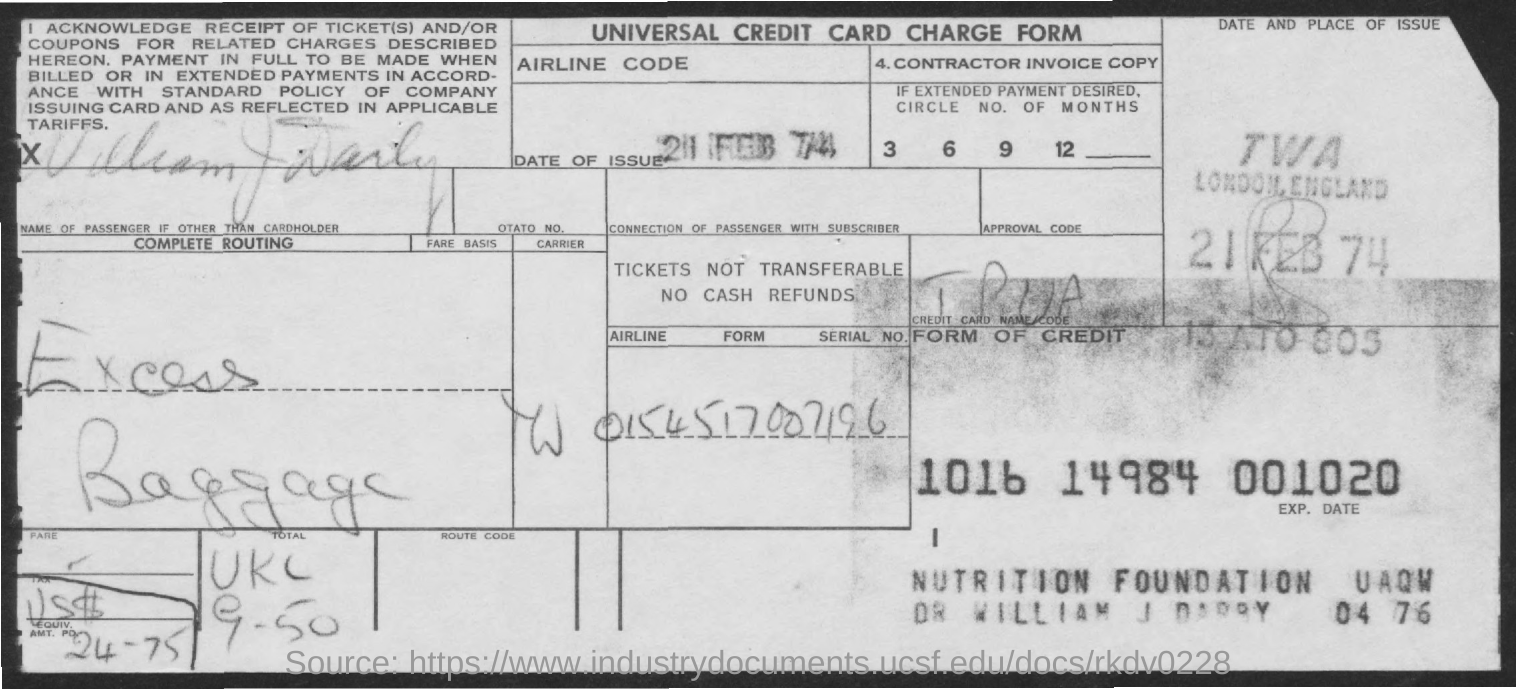What is this form about?
Ensure brevity in your answer.  UNIVERSAL CREDIT CARD CHARGE FORM. What is the date of issue?
Your answer should be compact. 21 feb 74. 